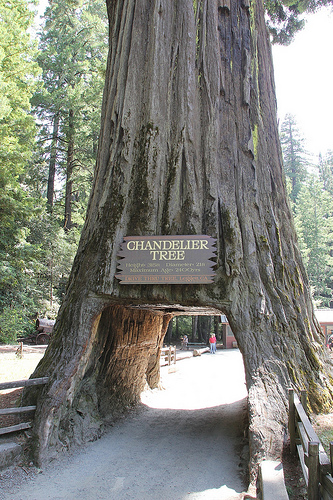<image>
Is there a road under the tree? Yes. The road is positioned underneath the tree, with the tree above it in the vertical space. Is the road next to the tree? No. The road is not positioned next to the tree. They are located in different areas of the scene. 